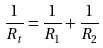Convert formula to latex. <formula><loc_0><loc_0><loc_500><loc_500>\frac { 1 } { R _ { t } } = \frac { 1 } { R _ { 1 } } + \frac { 1 } { R _ { 2 } }</formula> 